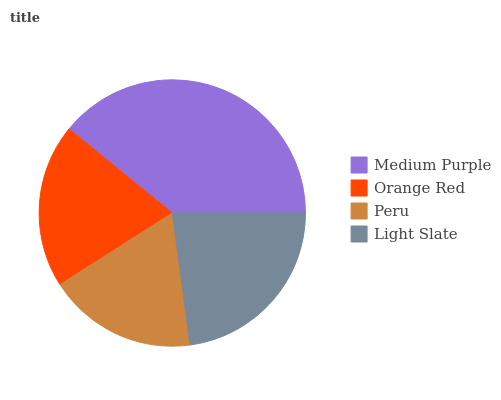Is Peru the minimum?
Answer yes or no. Yes. Is Medium Purple the maximum?
Answer yes or no. Yes. Is Orange Red the minimum?
Answer yes or no. No. Is Orange Red the maximum?
Answer yes or no. No. Is Medium Purple greater than Orange Red?
Answer yes or no. Yes. Is Orange Red less than Medium Purple?
Answer yes or no. Yes. Is Orange Red greater than Medium Purple?
Answer yes or no. No. Is Medium Purple less than Orange Red?
Answer yes or no. No. Is Light Slate the high median?
Answer yes or no. Yes. Is Orange Red the low median?
Answer yes or no. Yes. Is Orange Red the high median?
Answer yes or no. No. Is Peru the low median?
Answer yes or no. No. 